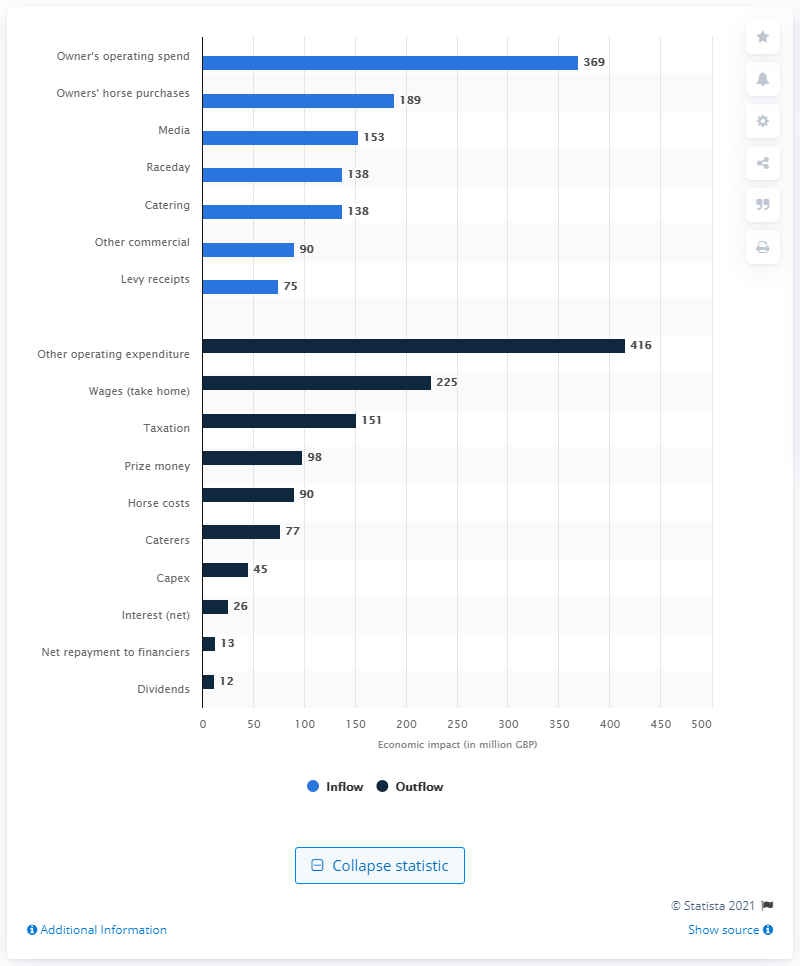Point out several critical features in this image. The raceday segment of the British horse racing industry generated £138 million in revenue in 2012. 